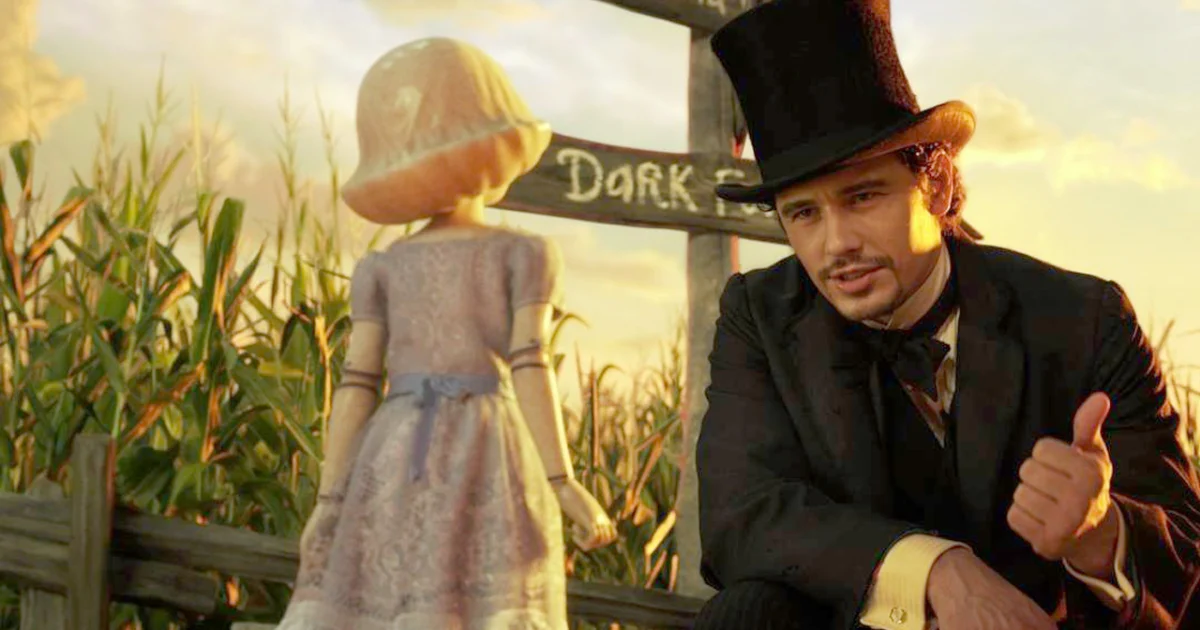What is the thematic significance of Oz's top hat in this context? The top hat Oz wears is not just a fashion statement but a narrative symbol as well. It signifies his role and status as a magician and a leader, which are central to his character development. In this scene, it represents his authority yet also his showman persona, highlighting the duality of his character - the public facade and the private vulnerability. Is there a symbolic interpretation to the 'Dark' sign in the background? Yes, the 'Dark' sign in the background intriguingly adds to the scene’s complexity. It could be hinting at the darker elements of the story or the personal challenges the characters face. It serves as a subtle reminder that their journey is not just through physically dark places but also through morally and emotionally challenging scenarios. 